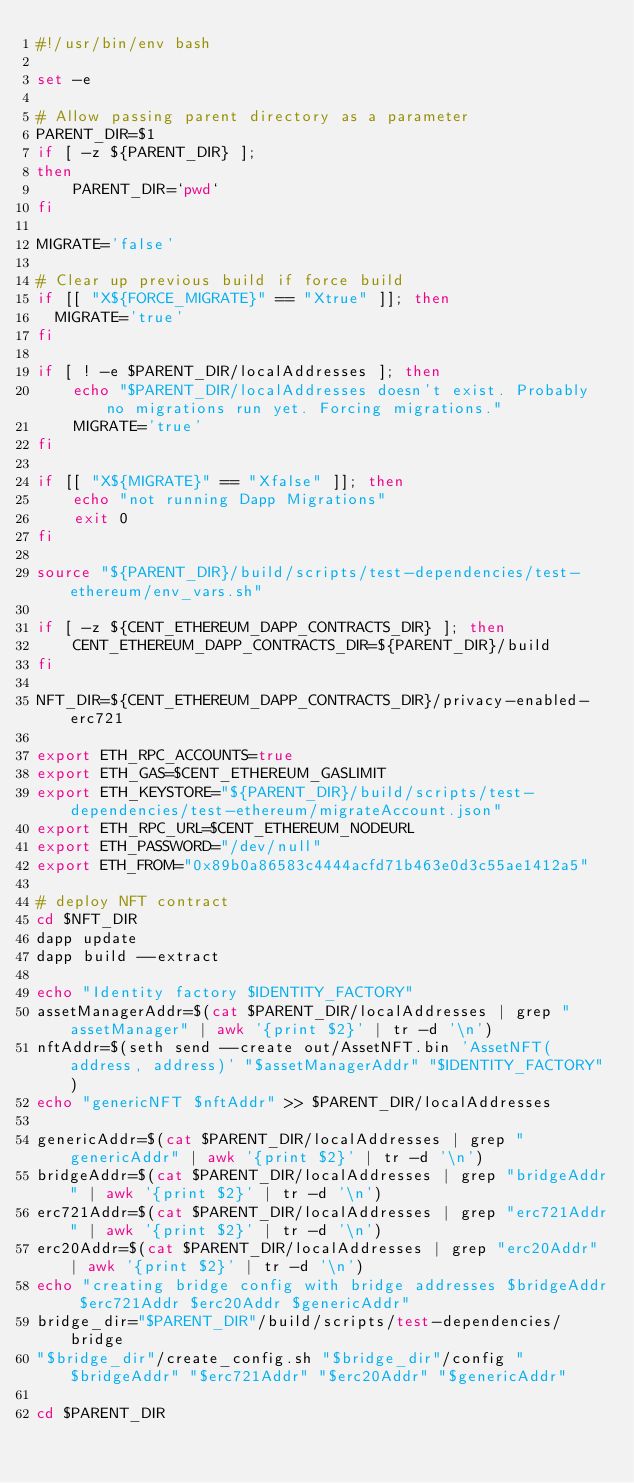Convert code to text. <code><loc_0><loc_0><loc_500><loc_500><_Bash_>#!/usr/bin/env bash

set -e

# Allow passing parent directory as a parameter
PARENT_DIR=$1
if [ -z ${PARENT_DIR} ];
then
    PARENT_DIR=`pwd`
fi

MIGRATE='false'

# Clear up previous build if force build
if [[ "X${FORCE_MIGRATE}" == "Xtrue" ]]; then
  MIGRATE='true'
fi

if [ ! -e $PARENT_DIR/localAddresses ]; then
    echo "$PARENT_DIR/localAddresses doesn't exist. Probably no migrations run yet. Forcing migrations."
    MIGRATE='true'
fi

if [[ "X${MIGRATE}" == "Xfalse" ]]; then
    echo "not running Dapp Migrations"
    exit 0
fi

source "${PARENT_DIR}/build/scripts/test-dependencies/test-ethereum/env_vars.sh"

if [ -z ${CENT_ETHEREUM_DAPP_CONTRACTS_DIR} ]; then
    CENT_ETHEREUM_DAPP_CONTRACTS_DIR=${PARENT_DIR}/build
fi

NFT_DIR=${CENT_ETHEREUM_DAPP_CONTRACTS_DIR}/privacy-enabled-erc721

export ETH_RPC_ACCOUNTS=true
export ETH_GAS=$CENT_ETHEREUM_GASLIMIT
export ETH_KEYSTORE="${PARENT_DIR}/build/scripts/test-dependencies/test-ethereum/migrateAccount.json"
export ETH_RPC_URL=$CENT_ETHEREUM_NODEURL
export ETH_PASSWORD="/dev/null"
export ETH_FROM="0x89b0a86583c4444acfd71b463e0d3c55ae1412a5"

# deploy NFT contract
cd $NFT_DIR
dapp update
dapp build --extract

echo "Identity factory $IDENTITY_FACTORY"
assetManagerAddr=$(cat $PARENT_DIR/localAddresses | grep "assetManager" | awk '{print $2}' | tr -d '\n')
nftAddr=$(seth send --create out/AssetNFT.bin 'AssetNFT(address, address)' "$assetManagerAddr" "$IDENTITY_FACTORY")
echo "genericNFT $nftAddr" >> $PARENT_DIR/localAddresses

genericAddr=$(cat $PARENT_DIR/localAddresses | grep "genericAddr" | awk '{print $2}' | tr -d '\n')
bridgeAddr=$(cat $PARENT_DIR/localAddresses | grep "bridgeAddr" | awk '{print $2}' | tr -d '\n')
erc721Addr=$(cat $PARENT_DIR/localAddresses | grep "erc721Addr" | awk '{print $2}' | tr -d '\n')
erc20Addr=$(cat $PARENT_DIR/localAddresses | grep "erc20Addr" | awk '{print $2}' | tr -d '\n')
echo "creating bridge config with bridge addresses $bridgeAddr $erc721Addr $erc20Addr $genericAddr"
bridge_dir="$PARENT_DIR"/build/scripts/test-dependencies/bridge
"$bridge_dir"/create_config.sh "$bridge_dir"/config "$bridgeAddr" "$erc721Addr" "$erc20Addr" "$genericAddr"

cd $PARENT_DIR
</code> 